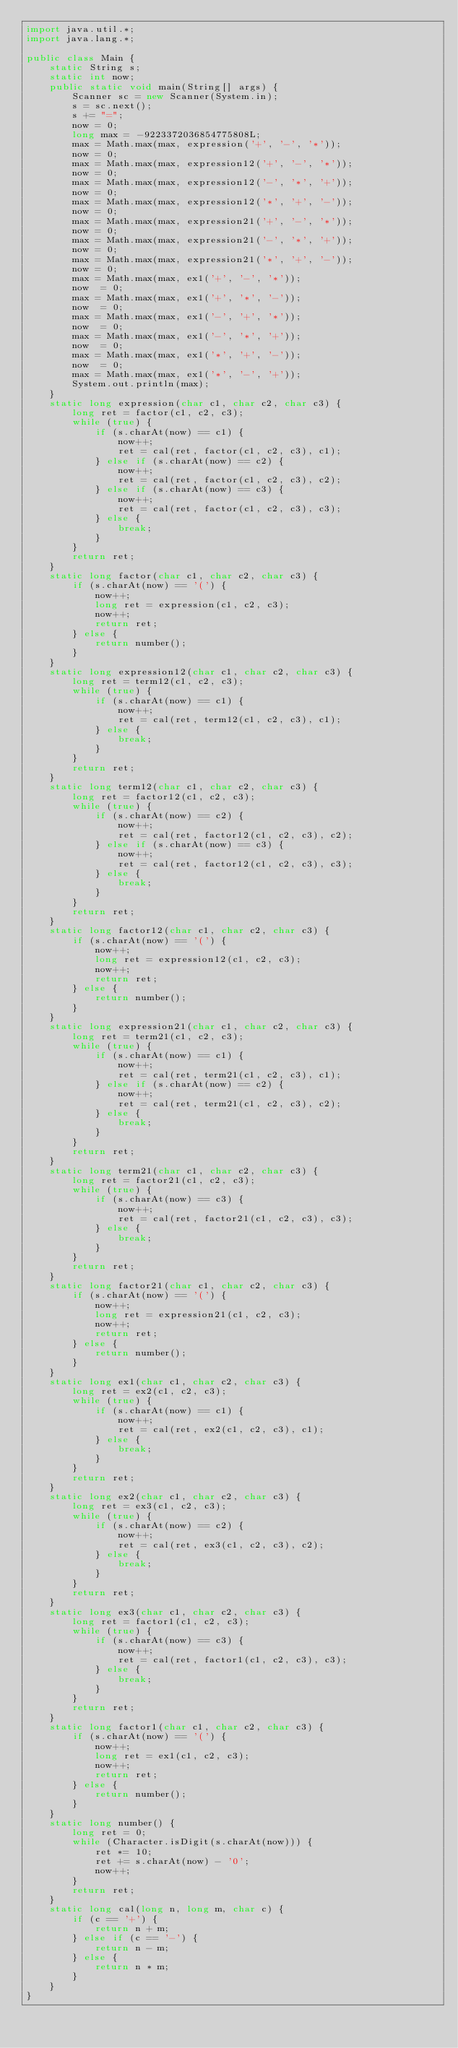<code> <loc_0><loc_0><loc_500><loc_500><_Java_>import java.util.*;
import java.lang.*;

public class Main {
	static String s;
	static int now;
	public static void main(String[] args) {
		Scanner sc = new Scanner(System.in);
		s = sc.next();
		s += "=";
		now = 0;
		long max = -9223372036854775808L;
		max = Math.max(max, expression('+', '-', '*'));
		now = 0;
		max = Math.max(max, expression12('+', '-', '*'));
		now = 0;
		max = Math.max(max, expression12('-', '*', '+'));
		now = 0;
		max = Math.max(max, expression12('*', '+', '-'));
		now = 0;
		max = Math.max(max, expression21('+', '-', '*'));
		now = 0;
		max = Math.max(max, expression21('-', '*', '+'));
		now = 0;
		max = Math.max(max, expression21('*', '+', '-'));
		now = 0;
		max = Math.max(max, ex1('+', '-', '*'));
		now  = 0;
		max = Math.max(max, ex1('+', '*', '-'));
		now  = 0;
		max = Math.max(max, ex1('-', '+', '*'));
		now  = 0;
		max = Math.max(max, ex1('-', '*', '+'));
		now  = 0;
		max = Math.max(max, ex1('*', '+', '-'));
		now  = 0;
		max = Math.max(max, ex1('*', '-', '+'));
		System.out.println(max);
	}
	static long expression(char c1, char c2, char c3) {
		long ret = factor(c1, c2, c3);
		while (true) {
			if (s.charAt(now) == c1) {
				now++;
				ret = cal(ret, factor(c1, c2, c3), c1);
			} else if (s.charAt(now) == c2) {
				now++;
				ret = cal(ret, factor(c1, c2, c3), c2);
			} else if (s.charAt(now) == c3) {
				now++;
				ret = cal(ret, factor(c1, c2, c3), c3);
			} else {
				break;
			}
		}
		return ret;
	}
	static long factor(char c1, char c2, char c3) {
		if (s.charAt(now) == '(') {
			now++;
			long ret = expression(c1, c2, c3);
			now++;
			return ret;
		} else {
			return number();
		}
	}
	static long expression12(char c1, char c2, char c3) {
		long ret = term12(c1, c2, c3);
		while (true) {
			if (s.charAt(now) == c1) {
				now++;
				ret = cal(ret, term12(c1, c2, c3), c1);
			} else {
				break;
			}
		}
		return ret;
	}
	static long term12(char c1, char c2, char c3) {
		long ret = factor12(c1, c2, c3);
		while (true) {
			if (s.charAt(now) == c2) {
				now++;
				ret = cal(ret, factor12(c1, c2, c3), c2);
			} else if (s.charAt(now) == c3) {
				now++;
				ret = cal(ret, factor12(c1, c2, c3), c3);
			} else {
				break;
			}
		}
		return ret;
	}
	static long factor12(char c1, char c2, char c3) {
		if (s.charAt(now) == '(') {
			now++;
			long ret = expression12(c1, c2, c3);
			now++;
			return ret;
		} else {
			return number();
		}
	}
	static long expression21(char c1, char c2, char c3) {
		long ret = term21(c1, c2, c3);
		while (true) {
			if (s.charAt(now) == c1) {
				now++;
				ret = cal(ret, term21(c1, c2, c3), c1);
			} else if (s.charAt(now) == c2) {
				now++;
				ret = cal(ret, term21(c1, c2, c3), c2);
			} else {
				break;
			}
		}
		return ret;
	}
	static long term21(char c1, char c2, char c3) {
		long ret = factor21(c1, c2, c3);
		while (true) {
			if (s.charAt(now) == c3) {
				now++;
				ret = cal(ret, factor21(c1, c2, c3), c3);
			} else {
				break;
			}
		}
		return ret;
	}
	static long factor21(char c1, char c2, char c3) {
		if (s.charAt(now) == '(') {
			now++;
			long ret = expression21(c1, c2, c3);
			now++;
			return ret;
		} else {
			return number();
		}
	}
	static long ex1(char c1, char c2, char c3) {
		long ret = ex2(c1, c2, c3);
		while (true) {
			if (s.charAt(now) == c1) {
				now++;
				ret = cal(ret, ex2(c1, c2, c3), c1);
			} else {
				break;
			}
		}
		return ret;
	}
	static long ex2(char c1, char c2, char c3) {
		long ret = ex3(c1, c2, c3);
		while (true) {
			if (s.charAt(now) == c2) {
				now++;
				ret = cal(ret, ex3(c1, c2, c3), c2);
			} else {
				break;
			}
		}
		return ret;
	}
	static long ex3(char c1, char c2, char c3) {
		long ret = factor1(c1, c2, c3);
		while (true) {
			if (s.charAt(now) == c3) {
				now++;
				ret = cal(ret, factor1(c1, c2, c3), c3);
			} else {
				break;
			}
		}
		return ret;
	}
	static long factor1(char c1, char c2, char c3) {
		if (s.charAt(now) == '(') {
			now++;
			long ret = ex1(c1, c2, c3);
			now++;
			return ret;
		} else {
			return number();
		}
	}
	static long number() {
		long ret = 0;
		while (Character.isDigit(s.charAt(now))) {
			ret *= 10;
			ret += s.charAt(now) - '0';
			now++;
		}
		return ret;
	}
	static long cal(long n, long m, char c) {
		if (c == '+') {
			return n + m;
		} else if (c == '-') {
			return n - m;
		} else {
			return n * m;
		}
	}
}


</code> 